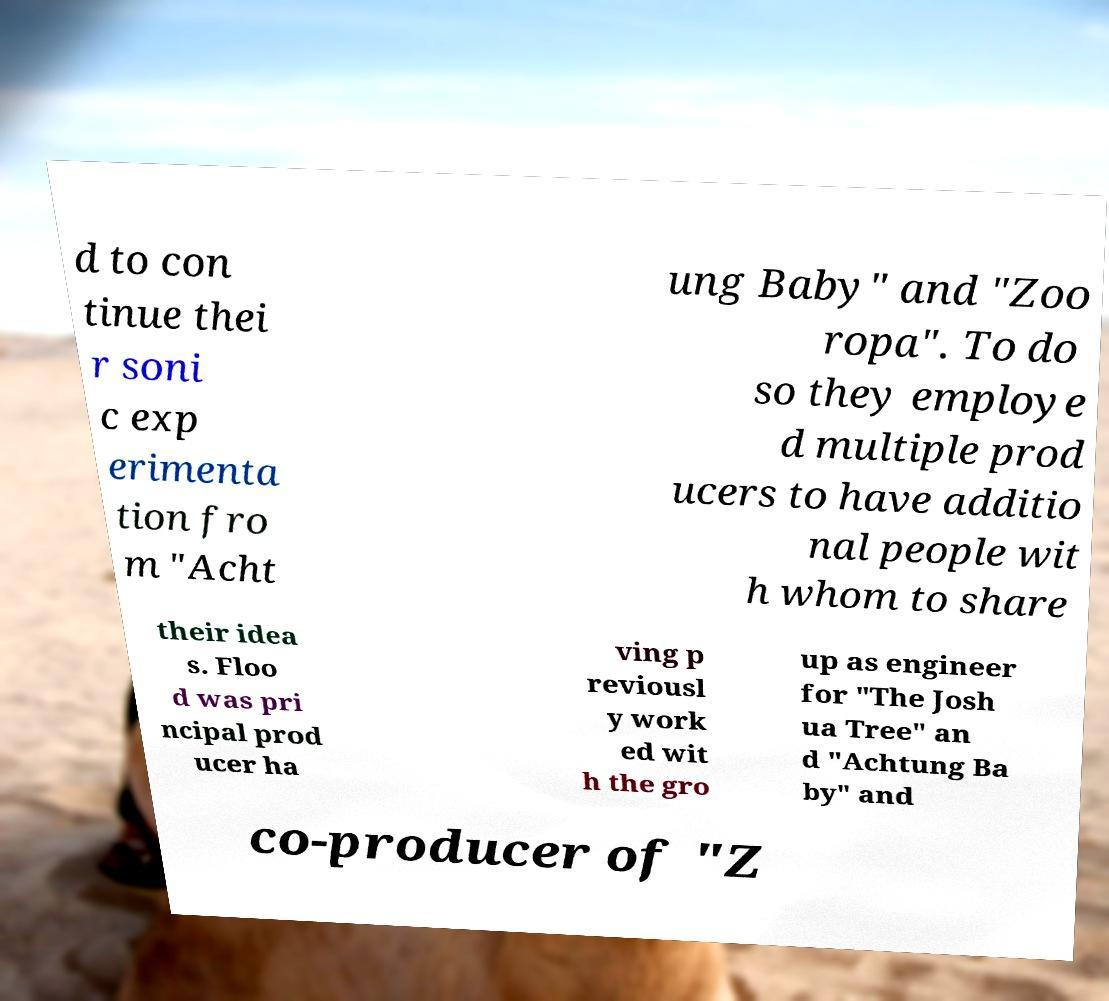Could you assist in decoding the text presented in this image and type it out clearly? d to con tinue thei r soni c exp erimenta tion fro m "Acht ung Baby" and "Zoo ropa". To do so they employe d multiple prod ucers to have additio nal people wit h whom to share their idea s. Floo d was pri ncipal prod ucer ha ving p reviousl y work ed wit h the gro up as engineer for "The Josh ua Tree" an d "Achtung Ba by" and co-producer of "Z 